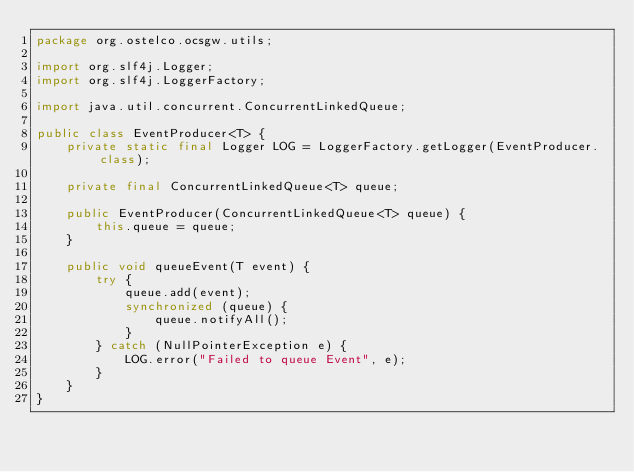<code> <loc_0><loc_0><loc_500><loc_500><_Java_>package org.ostelco.ocsgw.utils;

import org.slf4j.Logger;
import org.slf4j.LoggerFactory;

import java.util.concurrent.ConcurrentLinkedQueue;

public class EventProducer<T> {
    private static final Logger LOG = LoggerFactory.getLogger(EventProducer.class);

    private final ConcurrentLinkedQueue<T> queue;

    public EventProducer(ConcurrentLinkedQueue<T> queue) {
        this.queue = queue;
    }

    public void queueEvent(T event) {
        try {
            queue.add(event);
            synchronized (queue) {
                queue.notifyAll();
            }
        } catch (NullPointerException e) {
            LOG.error("Failed to queue Event", e);
        }
    }
}</code> 